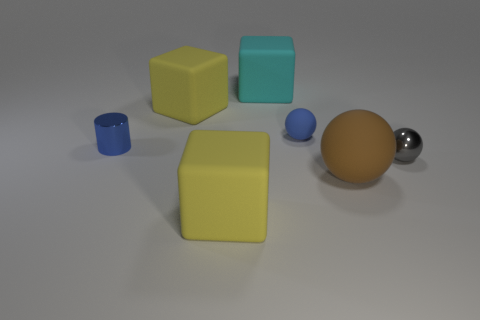Subtract all yellow rubber cubes. How many cubes are left? 1 Subtract all blue cylinders. How many yellow blocks are left? 2 Subtract 1 cubes. How many cubes are left? 2 Add 1 large cubes. How many objects exist? 8 Subtract all balls. How many objects are left? 4 Add 2 big cyan rubber objects. How many big cyan rubber objects are left? 3 Add 5 big blue metal cylinders. How many big blue metal cylinders exist? 5 Subtract 1 blue cylinders. How many objects are left? 6 Subtract all small blue matte balls. Subtract all small gray things. How many objects are left? 5 